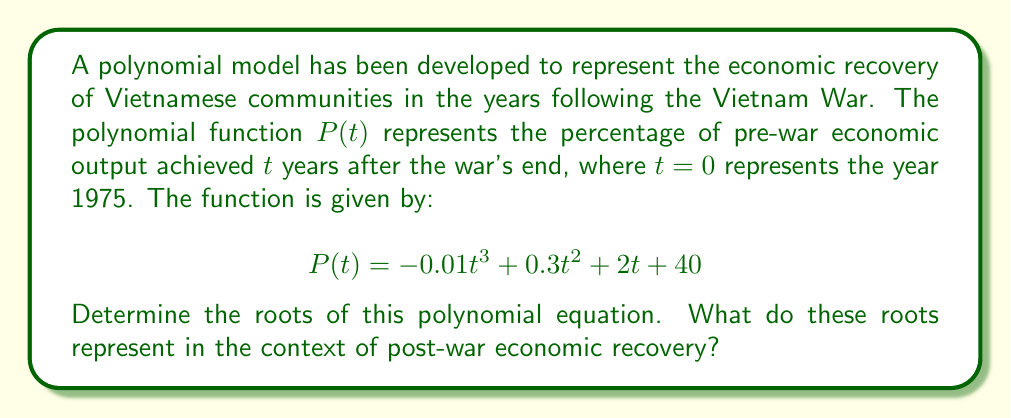Show me your answer to this math problem. To find the roots of the polynomial equation, we need to set $P(t) = 0$ and solve for $t$:

$$-0.01t^3 + 0.3t^2 + 2t + 40 = 0$$

This is a cubic equation, which can be challenging to solve by factoring. We can use the rational root theorem to find potential rational roots, then use synthetic division to verify and find the remaining factors.

Potential rational roots are factors of the constant term (40): ±1, ±2, ±4, ±5, ±8, ±10, ±20, ±40

Testing these values, we find that $t = -10$ is a root. Using synthetic division:

$$
\begin{array}{r}
-0.01 \enclose{longdiv}{1 \quad -30 \quad 200 \quad -400} \\
\underline{-10 \quad 100 \quad -700} \\
1 \quad -20 \quad 100 \quad 0
\end{array}
$$

The polynomial can be factored as:

$$P(t) = -0.01(t + 10)(t^2 - 20t + 100)$$

Using the quadratic formula on the remaining factor:

$$t = \frac{20 \pm \sqrt{400 - 400}}{2} = 10$$

Therefore, the roots of the polynomial are $t = -10$ and $t = 10$ (double root).

In the context of post-war economic recovery:

1. $t = -10$ represents 10 years before the war's end (1965). This root doesn't have a meaningful interpretation in our model, as it falls outside the domain of interest.

2. $t = 10$ (double root) represents 10 years after the war's end (1985). This indicates that the economic output reached 100% of pre-war levels in 1985, and the rate of change in economic growth was zero at this point, suggesting a potential inflection point in the recovery process.
Answer: The roots of the polynomial are $t = -10$ and $t = 10$ (double root). In the context of post-war economic recovery, the meaningful root $t = 10$ indicates that the economic output reached pre-war levels 10 years after the war's end, in 1985. 